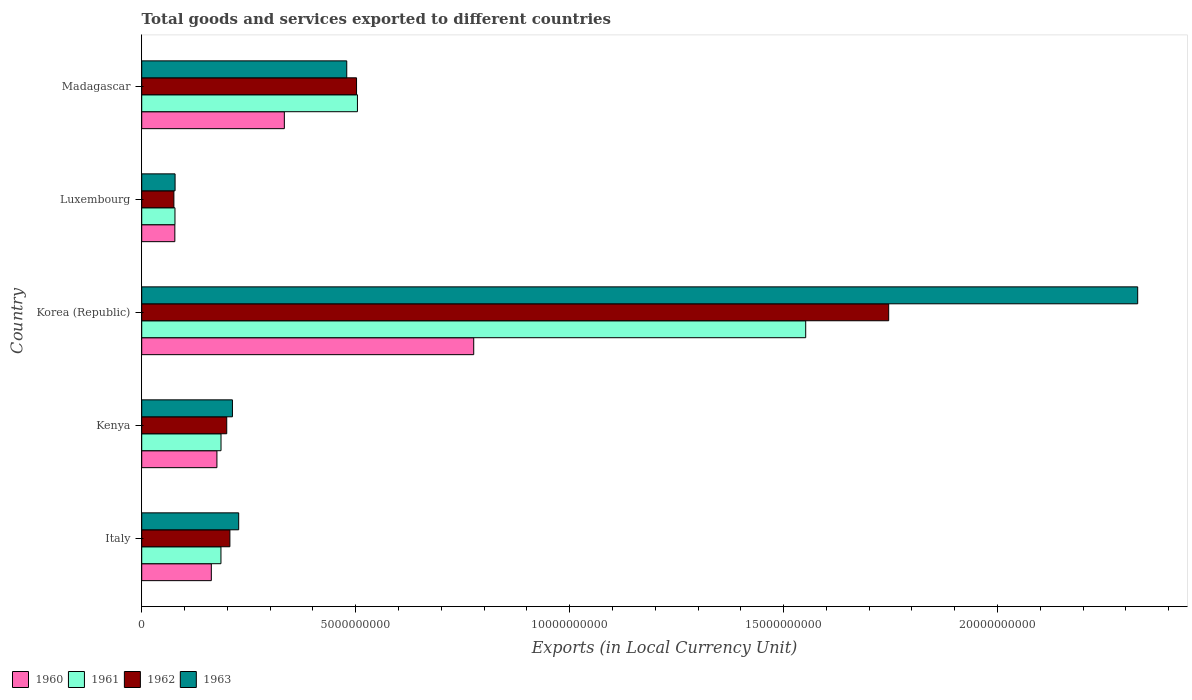How many different coloured bars are there?
Offer a terse response. 4. How many groups of bars are there?
Ensure brevity in your answer.  5. How many bars are there on the 4th tick from the top?
Ensure brevity in your answer.  4. What is the label of the 5th group of bars from the top?
Your answer should be compact. Italy. What is the Amount of goods and services exports in 1961 in Kenya?
Offer a very short reply. 1.85e+09. Across all countries, what is the maximum Amount of goods and services exports in 1960?
Make the answer very short. 7.76e+09. Across all countries, what is the minimum Amount of goods and services exports in 1962?
Keep it short and to the point. 7.52e+08. In which country was the Amount of goods and services exports in 1962 minimum?
Keep it short and to the point. Luxembourg. What is the total Amount of goods and services exports in 1960 in the graph?
Give a very brief answer. 1.52e+1. What is the difference between the Amount of goods and services exports in 1961 in Italy and that in Madagascar?
Provide a succinct answer. -3.19e+09. What is the difference between the Amount of goods and services exports in 1961 in Italy and the Amount of goods and services exports in 1963 in Kenya?
Offer a terse response. -2.68e+08. What is the average Amount of goods and services exports in 1962 per country?
Your response must be concise. 5.46e+09. What is the difference between the Amount of goods and services exports in 1960 and Amount of goods and services exports in 1963 in Madagascar?
Provide a short and direct response. -1.46e+09. What is the ratio of the Amount of goods and services exports in 1961 in Kenya to that in Korea (Republic)?
Make the answer very short. 0.12. Is the difference between the Amount of goods and services exports in 1960 in Kenya and Korea (Republic) greater than the difference between the Amount of goods and services exports in 1963 in Kenya and Korea (Republic)?
Keep it short and to the point. Yes. What is the difference between the highest and the second highest Amount of goods and services exports in 1960?
Provide a succinct answer. 4.43e+09. What is the difference between the highest and the lowest Amount of goods and services exports in 1963?
Give a very brief answer. 2.25e+1. Is the sum of the Amount of goods and services exports in 1960 in Italy and Kenya greater than the maximum Amount of goods and services exports in 1961 across all countries?
Ensure brevity in your answer.  No. Is it the case that in every country, the sum of the Amount of goods and services exports in 1961 and Amount of goods and services exports in 1960 is greater than the sum of Amount of goods and services exports in 1963 and Amount of goods and services exports in 1962?
Offer a terse response. No. Is it the case that in every country, the sum of the Amount of goods and services exports in 1961 and Amount of goods and services exports in 1963 is greater than the Amount of goods and services exports in 1960?
Ensure brevity in your answer.  Yes. Are all the bars in the graph horizontal?
Your answer should be compact. Yes. What is the difference between two consecutive major ticks on the X-axis?
Give a very brief answer. 5.00e+09. Are the values on the major ticks of X-axis written in scientific E-notation?
Ensure brevity in your answer.  No. Does the graph contain any zero values?
Your response must be concise. No. Does the graph contain grids?
Your answer should be compact. No. What is the title of the graph?
Your answer should be compact. Total goods and services exported to different countries. Does "1976" appear as one of the legend labels in the graph?
Your answer should be compact. No. What is the label or title of the X-axis?
Provide a short and direct response. Exports (in Local Currency Unit). What is the Exports (in Local Currency Unit) in 1960 in Italy?
Give a very brief answer. 1.63e+09. What is the Exports (in Local Currency Unit) in 1961 in Italy?
Make the answer very short. 1.85e+09. What is the Exports (in Local Currency Unit) in 1962 in Italy?
Offer a terse response. 2.06e+09. What is the Exports (in Local Currency Unit) of 1963 in Italy?
Ensure brevity in your answer.  2.27e+09. What is the Exports (in Local Currency Unit) of 1960 in Kenya?
Ensure brevity in your answer.  1.76e+09. What is the Exports (in Local Currency Unit) in 1961 in Kenya?
Your response must be concise. 1.85e+09. What is the Exports (in Local Currency Unit) in 1962 in Kenya?
Ensure brevity in your answer.  1.99e+09. What is the Exports (in Local Currency Unit) of 1963 in Kenya?
Your answer should be very brief. 2.12e+09. What is the Exports (in Local Currency Unit) in 1960 in Korea (Republic)?
Provide a succinct answer. 7.76e+09. What is the Exports (in Local Currency Unit) of 1961 in Korea (Republic)?
Offer a very short reply. 1.55e+1. What is the Exports (in Local Currency Unit) of 1962 in Korea (Republic)?
Give a very brief answer. 1.75e+1. What is the Exports (in Local Currency Unit) in 1963 in Korea (Republic)?
Give a very brief answer. 2.33e+1. What is the Exports (in Local Currency Unit) of 1960 in Luxembourg?
Your answer should be compact. 7.74e+08. What is the Exports (in Local Currency Unit) in 1961 in Luxembourg?
Offer a terse response. 7.77e+08. What is the Exports (in Local Currency Unit) of 1962 in Luxembourg?
Keep it short and to the point. 7.52e+08. What is the Exports (in Local Currency Unit) in 1963 in Luxembourg?
Offer a very short reply. 7.80e+08. What is the Exports (in Local Currency Unit) in 1960 in Madagascar?
Keep it short and to the point. 3.33e+09. What is the Exports (in Local Currency Unit) of 1961 in Madagascar?
Make the answer very short. 5.04e+09. What is the Exports (in Local Currency Unit) in 1962 in Madagascar?
Make the answer very short. 5.02e+09. What is the Exports (in Local Currency Unit) of 1963 in Madagascar?
Your answer should be compact. 4.79e+09. Across all countries, what is the maximum Exports (in Local Currency Unit) in 1960?
Offer a terse response. 7.76e+09. Across all countries, what is the maximum Exports (in Local Currency Unit) in 1961?
Keep it short and to the point. 1.55e+1. Across all countries, what is the maximum Exports (in Local Currency Unit) in 1962?
Offer a terse response. 1.75e+1. Across all countries, what is the maximum Exports (in Local Currency Unit) of 1963?
Ensure brevity in your answer.  2.33e+1. Across all countries, what is the minimum Exports (in Local Currency Unit) in 1960?
Provide a short and direct response. 7.74e+08. Across all countries, what is the minimum Exports (in Local Currency Unit) of 1961?
Give a very brief answer. 7.77e+08. Across all countries, what is the minimum Exports (in Local Currency Unit) in 1962?
Keep it short and to the point. 7.52e+08. Across all countries, what is the minimum Exports (in Local Currency Unit) of 1963?
Provide a succinct answer. 7.80e+08. What is the total Exports (in Local Currency Unit) of 1960 in the graph?
Your answer should be very brief. 1.52e+1. What is the total Exports (in Local Currency Unit) of 1961 in the graph?
Your answer should be compact. 2.50e+1. What is the total Exports (in Local Currency Unit) of 1962 in the graph?
Offer a very short reply. 2.73e+1. What is the total Exports (in Local Currency Unit) in 1963 in the graph?
Offer a terse response. 3.32e+1. What is the difference between the Exports (in Local Currency Unit) of 1960 in Italy and that in Kenya?
Keep it short and to the point. -1.31e+08. What is the difference between the Exports (in Local Currency Unit) of 1961 in Italy and that in Kenya?
Keep it short and to the point. -1.45e+06. What is the difference between the Exports (in Local Currency Unit) of 1962 in Italy and that in Kenya?
Your answer should be very brief. 7.40e+07. What is the difference between the Exports (in Local Currency Unit) of 1963 in Italy and that in Kenya?
Your response must be concise. 1.46e+08. What is the difference between the Exports (in Local Currency Unit) in 1960 in Italy and that in Korea (Republic)?
Offer a very short reply. -6.13e+09. What is the difference between the Exports (in Local Currency Unit) in 1961 in Italy and that in Korea (Republic)?
Offer a terse response. -1.37e+1. What is the difference between the Exports (in Local Currency Unit) in 1962 in Italy and that in Korea (Republic)?
Keep it short and to the point. -1.54e+1. What is the difference between the Exports (in Local Currency Unit) in 1963 in Italy and that in Korea (Republic)?
Your answer should be compact. -2.10e+1. What is the difference between the Exports (in Local Currency Unit) in 1960 in Italy and that in Luxembourg?
Provide a short and direct response. 8.53e+08. What is the difference between the Exports (in Local Currency Unit) in 1961 in Italy and that in Luxembourg?
Make the answer very short. 1.07e+09. What is the difference between the Exports (in Local Currency Unit) of 1962 in Italy and that in Luxembourg?
Your response must be concise. 1.31e+09. What is the difference between the Exports (in Local Currency Unit) of 1963 in Italy and that in Luxembourg?
Keep it short and to the point. 1.49e+09. What is the difference between the Exports (in Local Currency Unit) in 1960 in Italy and that in Madagascar?
Keep it short and to the point. -1.71e+09. What is the difference between the Exports (in Local Currency Unit) of 1961 in Italy and that in Madagascar?
Keep it short and to the point. -3.19e+09. What is the difference between the Exports (in Local Currency Unit) of 1962 in Italy and that in Madagascar?
Give a very brief answer. -2.96e+09. What is the difference between the Exports (in Local Currency Unit) in 1963 in Italy and that in Madagascar?
Your response must be concise. -2.53e+09. What is the difference between the Exports (in Local Currency Unit) of 1960 in Kenya and that in Korea (Republic)?
Offer a very short reply. -6.00e+09. What is the difference between the Exports (in Local Currency Unit) in 1961 in Kenya and that in Korea (Republic)?
Offer a terse response. -1.37e+1. What is the difference between the Exports (in Local Currency Unit) of 1962 in Kenya and that in Korea (Republic)?
Give a very brief answer. -1.55e+1. What is the difference between the Exports (in Local Currency Unit) of 1963 in Kenya and that in Korea (Republic)?
Make the answer very short. -2.12e+1. What is the difference between the Exports (in Local Currency Unit) in 1960 in Kenya and that in Luxembourg?
Provide a short and direct response. 9.84e+08. What is the difference between the Exports (in Local Currency Unit) of 1961 in Kenya and that in Luxembourg?
Your answer should be very brief. 1.08e+09. What is the difference between the Exports (in Local Currency Unit) in 1962 in Kenya and that in Luxembourg?
Your answer should be compact. 1.23e+09. What is the difference between the Exports (in Local Currency Unit) in 1963 in Kenya and that in Luxembourg?
Give a very brief answer. 1.34e+09. What is the difference between the Exports (in Local Currency Unit) of 1960 in Kenya and that in Madagascar?
Ensure brevity in your answer.  -1.58e+09. What is the difference between the Exports (in Local Currency Unit) in 1961 in Kenya and that in Madagascar?
Your answer should be compact. -3.19e+09. What is the difference between the Exports (in Local Currency Unit) of 1962 in Kenya and that in Madagascar?
Offer a very short reply. -3.03e+09. What is the difference between the Exports (in Local Currency Unit) in 1963 in Kenya and that in Madagascar?
Keep it short and to the point. -2.67e+09. What is the difference between the Exports (in Local Currency Unit) in 1960 in Korea (Republic) and that in Luxembourg?
Your answer should be compact. 6.98e+09. What is the difference between the Exports (in Local Currency Unit) of 1961 in Korea (Republic) and that in Luxembourg?
Offer a terse response. 1.47e+1. What is the difference between the Exports (in Local Currency Unit) in 1962 in Korea (Republic) and that in Luxembourg?
Keep it short and to the point. 1.67e+1. What is the difference between the Exports (in Local Currency Unit) in 1963 in Korea (Republic) and that in Luxembourg?
Make the answer very short. 2.25e+1. What is the difference between the Exports (in Local Currency Unit) of 1960 in Korea (Republic) and that in Madagascar?
Offer a very short reply. 4.43e+09. What is the difference between the Exports (in Local Currency Unit) of 1961 in Korea (Republic) and that in Madagascar?
Make the answer very short. 1.05e+1. What is the difference between the Exports (in Local Currency Unit) in 1962 in Korea (Republic) and that in Madagascar?
Keep it short and to the point. 1.24e+1. What is the difference between the Exports (in Local Currency Unit) in 1963 in Korea (Republic) and that in Madagascar?
Your answer should be very brief. 1.85e+1. What is the difference between the Exports (in Local Currency Unit) in 1960 in Luxembourg and that in Madagascar?
Provide a succinct answer. -2.56e+09. What is the difference between the Exports (in Local Currency Unit) in 1961 in Luxembourg and that in Madagascar?
Provide a succinct answer. -4.26e+09. What is the difference between the Exports (in Local Currency Unit) of 1962 in Luxembourg and that in Madagascar?
Your answer should be very brief. -4.27e+09. What is the difference between the Exports (in Local Currency Unit) in 1963 in Luxembourg and that in Madagascar?
Provide a short and direct response. -4.01e+09. What is the difference between the Exports (in Local Currency Unit) in 1960 in Italy and the Exports (in Local Currency Unit) in 1961 in Kenya?
Provide a succinct answer. -2.27e+08. What is the difference between the Exports (in Local Currency Unit) in 1960 in Italy and the Exports (in Local Currency Unit) in 1962 in Kenya?
Make the answer very short. -3.60e+08. What is the difference between the Exports (in Local Currency Unit) of 1960 in Italy and the Exports (in Local Currency Unit) of 1963 in Kenya?
Provide a succinct answer. -4.94e+08. What is the difference between the Exports (in Local Currency Unit) in 1961 in Italy and the Exports (in Local Currency Unit) in 1962 in Kenya?
Your answer should be compact. -1.35e+08. What is the difference between the Exports (in Local Currency Unit) of 1961 in Italy and the Exports (in Local Currency Unit) of 1963 in Kenya?
Make the answer very short. -2.68e+08. What is the difference between the Exports (in Local Currency Unit) of 1962 in Italy and the Exports (in Local Currency Unit) of 1963 in Kenya?
Provide a short and direct response. -5.95e+07. What is the difference between the Exports (in Local Currency Unit) of 1960 in Italy and the Exports (in Local Currency Unit) of 1961 in Korea (Republic)?
Give a very brief answer. -1.39e+1. What is the difference between the Exports (in Local Currency Unit) in 1960 in Italy and the Exports (in Local Currency Unit) in 1962 in Korea (Republic)?
Your answer should be very brief. -1.58e+1. What is the difference between the Exports (in Local Currency Unit) in 1960 in Italy and the Exports (in Local Currency Unit) in 1963 in Korea (Republic)?
Your answer should be very brief. -2.16e+1. What is the difference between the Exports (in Local Currency Unit) of 1961 in Italy and the Exports (in Local Currency Unit) of 1962 in Korea (Republic)?
Provide a succinct answer. -1.56e+1. What is the difference between the Exports (in Local Currency Unit) of 1961 in Italy and the Exports (in Local Currency Unit) of 1963 in Korea (Republic)?
Offer a very short reply. -2.14e+1. What is the difference between the Exports (in Local Currency Unit) of 1962 in Italy and the Exports (in Local Currency Unit) of 1963 in Korea (Republic)?
Make the answer very short. -2.12e+1. What is the difference between the Exports (in Local Currency Unit) in 1960 in Italy and the Exports (in Local Currency Unit) in 1961 in Luxembourg?
Ensure brevity in your answer.  8.50e+08. What is the difference between the Exports (in Local Currency Unit) of 1960 in Italy and the Exports (in Local Currency Unit) of 1962 in Luxembourg?
Keep it short and to the point. 8.75e+08. What is the difference between the Exports (in Local Currency Unit) of 1960 in Italy and the Exports (in Local Currency Unit) of 1963 in Luxembourg?
Your answer should be very brief. 8.47e+08. What is the difference between the Exports (in Local Currency Unit) in 1961 in Italy and the Exports (in Local Currency Unit) in 1962 in Luxembourg?
Your answer should be compact. 1.10e+09. What is the difference between the Exports (in Local Currency Unit) of 1961 in Italy and the Exports (in Local Currency Unit) of 1963 in Luxembourg?
Offer a terse response. 1.07e+09. What is the difference between the Exports (in Local Currency Unit) in 1962 in Italy and the Exports (in Local Currency Unit) in 1963 in Luxembourg?
Your response must be concise. 1.28e+09. What is the difference between the Exports (in Local Currency Unit) in 1960 in Italy and the Exports (in Local Currency Unit) in 1961 in Madagascar?
Provide a succinct answer. -3.41e+09. What is the difference between the Exports (in Local Currency Unit) of 1960 in Italy and the Exports (in Local Currency Unit) of 1962 in Madagascar?
Your answer should be compact. -3.39e+09. What is the difference between the Exports (in Local Currency Unit) in 1960 in Italy and the Exports (in Local Currency Unit) in 1963 in Madagascar?
Offer a terse response. -3.16e+09. What is the difference between the Exports (in Local Currency Unit) in 1961 in Italy and the Exports (in Local Currency Unit) in 1962 in Madagascar?
Your answer should be compact. -3.17e+09. What is the difference between the Exports (in Local Currency Unit) of 1961 in Italy and the Exports (in Local Currency Unit) of 1963 in Madagascar?
Keep it short and to the point. -2.94e+09. What is the difference between the Exports (in Local Currency Unit) of 1962 in Italy and the Exports (in Local Currency Unit) of 1963 in Madagascar?
Offer a very short reply. -2.73e+09. What is the difference between the Exports (in Local Currency Unit) of 1960 in Kenya and the Exports (in Local Currency Unit) of 1961 in Korea (Republic)?
Your response must be concise. -1.38e+1. What is the difference between the Exports (in Local Currency Unit) in 1960 in Kenya and the Exports (in Local Currency Unit) in 1962 in Korea (Republic)?
Your response must be concise. -1.57e+1. What is the difference between the Exports (in Local Currency Unit) of 1960 in Kenya and the Exports (in Local Currency Unit) of 1963 in Korea (Republic)?
Provide a short and direct response. -2.15e+1. What is the difference between the Exports (in Local Currency Unit) of 1961 in Kenya and the Exports (in Local Currency Unit) of 1962 in Korea (Republic)?
Ensure brevity in your answer.  -1.56e+1. What is the difference between the Exports (in Local Currency Unit) in 1961 in Kenya and the Exports (in Local Currency Unit) in 1963 in Korea (Republic)?
Your answer should be very brief. -2.14e+1. What is the difference between the Exports (in Local Currency Unit) of 1962 in Kenya and the Exports (in Local Currency Unit) of 1963 in Korea (Republic)?
Provide a succinct answer. -2.13e+1. What is the difference between the Exports (in Local Currency Unit) in 1960 in Kenya and the Exports (in Local Currency Unit) in 1961 in Luxembourg?
Give a very brief answer. 9.81e+08. What is the difference between the Exports (in Local Currency Unit) of 1960 in Kenya and the Exports (in Local Currency Unit) of 1962 in Luxembourg?
Ensure brevity in your answer.  1.01e+09. What is the difference between the Exports (in Local Currency Unit) in 1960 in Kenya and the Exports (in Local Currency Unit) in 1963 in Luxembourg?
Offer a very short reply. 9.78e+08. What is the difference between the Exports (in Local Currency Unit) in 1961 in Kenya and the Exports (in Local Currency Unit) in 1962 in Luxembourg?
Keep it short and to the point. 1.10e+09. What is the difference between the Exports (in Local Currency Unit) of 1961 in Kenya and the Exports (in Local Currency Unit) of 1963 in Luxembourg?
Ensure brevity in your answer.  1.07e+09. What is the difference between the Exports (in Local Currency Unit) of 1962 in Kenya and the Exports (in Local Currency Unit) of 1963 in Luxembourg?
Your response must be concise. 1.21e+09. What is the difference between the Exports (in Local Currency Unit) of 1960 in Kenya and the Exports (in Local Currency Unit) of 1961 in Madagascar?
Make the answer very short. -3.28e+09. What is the difference between the Exports (in Local Currency Unit) in 1960 in Kenya and the Exports (in Local Currency Unit) in 1962 in Madagascar?
Keep it short and to the point. -3.26e+09. What is the difference between the Exports (in Local Currency Unit) in 1960 in Kenya and the Exports (in Local Currency Unit) in 1963 in Madagascar?
Ensure brevity in your answer.  -3.03e+09. What is the difference between the Exports (in Local Currency Unit) in 1961 in Kenya and the Exports (in Local Currency Unit) in 1962 in Madagascar?
Your response must be concise. -3.17e+09. What is the difference between the Exports (in Local Currency Unit) of 1961 in Kenya and the Exports (in Local Currency Unit) of 1963 in Madagascar?
Offer a very short reply. -2.94e+09. What is the difference between the Exports (in Local Currency Unit) in 1962 in Kenya and the Exports (in Local Currency Unit) in 1963 in Madagascar?
Provide a short and direct response. -2.80e+09. What is the difference between the Exports (in Local Currency Unit) of 1960 in Korea (Republic) and the Exports (in Local Currency Unit) of 1961 in Luxembourg?
Your response must be concise. 6.98e+09. What is the difference between the Exports (in Local Currency Unit) of 1960 in Korea (Republic) and the Exports (in Local Currency Unit) of 1962 in Luxembourg?
Offer a very short reply. 7.01e+09. What is the difference between the Exports (in Local Currency Unit) of 1960 in Korea (Republic) and the Exports (in Local Currency Unit) of 1963 in Luxembourg?
Make the answer very short. 6.98e+09. What is the difference between the Exports (in Local Currency Unit) of 1961 in Korea (Republic) and the Exports (in Local Currency Unit) of 1962 in Luxembourg?
Offer a terse response. 1.48e+1. What is the difference between the Exports (in Local Currency Unit) in 1961 in Korea (Republic) and the Exports (in Local Currency Unit) in 1963 in Luxembourg?
Offer a terse response. 1.47e+1. What is the difference between the Exports (in Local Currency Unit) of 1962 in Korea (Republic) and the Exports (in Local Currency Unit) of 1963 in Luxembourg?
Make the answer very short. 1.67e+1. What is the difference between the Exports (in Local Currency Unit) in 1960 in Korea (Republic) and the Exports (in Local Currency Unit) in 1961 in Madagascar?
Keep it short and to the point. 2.72e+09. What is the difference between the Exports (in Local Currency Unit) of 1960 in Korea (Republic) and the Exports (in Local Currency Unit) of 1962 in Madagascar?
Your answer should be very brief. 2.74e+09. What is the difference between the Exports (in Local Currency Unit) of 1960 in Korea (Republic) and the Exports (in Local Currency Unit) of 1963 in Madagascar?
Provide a succinct answer. 2.97e+09. What is the difference between the Exports (in Local Currency Unit) in 1961 in Korea (Republic) and the Exports (in Local Currency Unit) in 1962 in Madagascar?
Your answer should be compact. 1.05e+1. What is the difference between the Exports (in Local Currency Unit) in 1961 in Korea (Republic) and the Exports (in Local Currency Unit) in 1963 in Madagascar?
Your answer should be compact. 1.07e+1. What is the difference between the Exports (in Local Currency Unit) of 1962 in Korea (Republic) and the Exports (in Local Currency Unit) of 1963 in Madagascar?
Provide a short and direct response. 1.27e+1. What is the difference between the Exports (in Local Currency Unit) in 1960 in Luxembourg and the Exports (in Local Currency Unit) in 1961 in Madagascar?
Your response must be concise. -4.27e+09. What is the difference between the Exports (in Local Currency Unit) in 1960 in Luxembourg and the Exports (in Local Currency Unit) in 1962 in Madagascar?
Keep it short and to the point. -4.25e+09. What is the difference between the Exports (in Local Currency Unit) in 1960 in Luxembourg and the Exports (in Local Currency Unit) in 1963 in Madagascar?
Offer a terse response. -4.02e+09. What is the difference between the Exports (in Local Currency Unit) in 1961 in Luxembourg and the Exports (in Local Currency Unit) in 1962 in Madagascar?
Make the answer very short. -4.24e+09. What is the difference between the Exports (in Local Currency Unit) in 1961 in Luxembourg and the Exports (in Local Currency Unit) in 1963 in Madagascar?
Your answer should be compact. -4.01e+09. What is the difference between the Exports (in Local Currency Unit) in 1962 in Luxembourg and the Exports (in Local Currency Unit) in 1963 in Madagascar?
Offer a very short reply. -4.04e+09. What is the average Exports (in Local Currency Unit) in 1960 per country?
Ensure brevity in your answer.  3.05e+09. What is the average Exports (in Local Currency Unit) of 1961 per country?
Offer a terse response. 5.01e+09. What is the average Exports (in Local Currency Unit) of 1962 per country?
Provide a short and direct response. 5.46e+09. What is the average Exports (in Local Currency Unit) in 1963 per country?
Provide a short and direct response. 6.65e+09. What is the difference between the Exports (in Local Currency Unit) in 1960 and Exports (in Local Currency Unit) in 1961 in Italy?
Offer a terse response. -2.25e+08. What is the difference between the Exports (in Local Currency Unit) of 1960 and Exports (in Local Currency Unit) of 1962 in Italy?
Keep it short and to the point. -4.34e+08. What is the difference between the Exports (in Local Currency Unit) in 1960 and Exports (in Local Currency Unit) in 1963 in Italy?
Offer a very short reply. -6.40e+08. What is the difference between the Exports (in Local Currency Unit) of 1961 and Exports (in Local Currency Unit) of 1962 in Italy?
Offer a terse response. -2.09e+08. What is the difference between the Exports (in Local Currency Unit) of 1961 and Exports (in Local Currency Unit) of 1963 in Italy?
Give a very brief answer. -4.14e+08. What is the difference between the Exports (in Local Currency Unit) in 1962 and Exports (in Local Currency Unit) in 1963 in Italy?
Your answer should be very brief. -2.05e+08. What is the difference between the Exports (in Local Currency Unit) of 1960 and Exports (in Local Currency Unit) of 1961 in Kenya?
Your answer should be compact. -9.56e+07. What is the difference between the Exports (in Local Currency Unit) in 1960 and Exports (in Local Currency Unit) in 1962 in Kenya?
Provide a succinct answer. -2.29e+08. What is the difference between the Exports (in Local Currency Unit) in 1960 and Exports (in Local Currency Unit) in 1963 in Kenya?
Your answer should be very brief. -3.63e+08. What is the difference between the Exports (in Local Currency Unit) in 1961 and Exports (in Local Currency Unit) in 1962 in Kenya?
Give a very brief answer. -1.33e+08. What is the difference between the Exports (in Local Currency Unit) of 1961 and Exports (in Local Currency Unit) of 1963 in Kenya?
Provide a succinct answer. -2.67e+08. What is the difference between the Exports (in Local Currency Unit) of 1962 and Exports (in Local Currency Unit) of 1963 in Kenya?
Keep it short and to the point. -1.34e+08. What is the difference between the Exports (in Local Currency Unit) in 1960 and Exports (in Local Currency Unit) in 1961 in Korea (Republic)?
Ensure brevity in your answer.  -7.76e+09. What is the difference between the Exports (in Local Currency Unit) in 1960 and Exports (in Local Currency Unit) in 1962 in Korea (Republic)?
Provide a succinct answer. -9.70e+09. What is the difference between the Exports (in Local Currency Unit) in 1960 and Exports (in Local Currency Unit) in 1963 in Korea (Republic)?
Offer a terse response. -1.55e+1. What is the difference between the Exports (in Local Currency Unit) of 1961 and Exports (in Local Currency Unit) of 1962 in Korea (Republic)?
Offer a terse response. -1.94e+09. What is the difference between the Exports (in Local Currency Unit) of 1961 and Exports (in Local Currency Unit) of 1963 in Korea (Republic)?
Offer a terse response. -7.76e+09. What is the difference between the Exports (in Local Currency Unit) in 1962 and Exports (in Local Currency Unit) in 1963 in Korea (Republic)?
Your answer should be compact. -5.82e+09. What is the difference between the Exports (in Local Currency Unit) in 1960 and Exports (in Local Currency Unit) in 1961 in Luxembourg?
Provide a short and direct response. -2.86e+06. What is the difference between the Exports (in Local Currency Unit) in 1960 and Exports (in Local Currency Unit) in 1962 in Luxembourg?
Give a very brief answer. 2.23e+07. What is the difference between the Exports (in Local Currency Unit) of 1960 and Exports (in Local Currency Unit) of 1963 in Luxembourg?
Your response must be concise. -5.65e+06. What is the difference between the Exports (in Local Currency Unit) of 1961 and Exports (in Local Currency Unit) of 1962 in Luxembourg?
Ensure brevity in your answer.  2.52e+07. What is the difference between the Exports (in Local Currency Unit) of 1961 and Exports (in Local Currency Unit) of 1963 in Luxembourg?
Offer a terse response. -2.79e+06. What is the difference between the Exports (in Local Currency Unit) in 1962 and Exports (in Local Currency Unit) in 1963 in Luxembourg?
Offer a terse response. -2.80e+07. What is the difference between the Exports (in Local Currency Unit) of 1960 and Exports (in Local Currency Unit) of 1961 in Madagascar?
Ensure brevity in your answer.  -1.71e+09. What is the difference between the Exports (in Local Currency Unit) of 1960 and Exports (in Local Currency Unit) of 1962 in Madagascar?
Your answer should be compact. -1.69e+09. What is the difference between the Exports (in Local Currency Unit) in 1960 and Exports (in Local Currency Unit) in 1963 in Madagascar?
Give a very brief answer. -1.46e+09. What is the difference between the Exports (in Local Currency Unit) of 1961 and Exports (in Local Currency Unit) of 1962 in Madagascar?
Provide a short and direct response. 2.08e+07. What is the difference between the Exports (in Local Currency Unit) in 1961 and Exports (in Local Currency Unit) in 1963 in Madagascar?
Offer a very short reply. 2.50e+08. What is the difference between the Exports (in Local Currency Unit) of 1962 and Exports (in Local Currency Unit) of 1963 in Madagascar?
Offer a terse response. 2.29e+08. What is the ratio of the Exports (in Local Currency Unit) in 1960 in Italy to that in Kenya?
Your response must be concise. 0.93. What is the ratio of the Exports (in Local Currency Unit) of 1961 in Italy to that in Kenya?
Make the answer very short. 1. What is the ratio of the Exports (in Local Currency Unit) of 1962 in Italy to that in Kenya?
Ensure brevity in your answer.  1.04. What is the ratio of the Exports (in Local Currency Unit) of 1963 in Italy to that in Kenya?
Your response must be concise. 1.07. What is the ratio of the Exports (in Local Currency Unit) of 1960 in Italy to that in Korea (Republic)?
Your answer should be very brief. 0.21. What is the ratio of the Exports (in Local Currency Unit) of 1961 in Italy to that in Korea (Republic)?
Make the answer very short. 0.12. What is the ratio of the Exports (in Local Currency Unit) in 1962 in Italy to that in Korea (Republic)?
Make the answer very short. 0.12. What is the ratio of the Exports (in Local Currency Unit) in 1963 in Italy to that in Korea (Republic)?
Give a very brief answer. 0.1. What is the ratio of the Exports (in Local Currency Unit) of 1960 in Italy to that in Luxembourg?
Provide a succinct answer. 2.1. What is the ratio of the Exports (in Local Currency Unit) of 1961 in Italy to that in Luxembourg?
Your response must be concise. 2.38. What is the ratio of the Exports (in Local Currency Unit) of 1962 in Italy to that in Luxembourg?
Your response must be concise. 2.74. What is the ratio of the Exports (in Local Currency Unit) of 1963 in Italy to that in Luxembourg?
Offer a very short reply. 2.91. What is the ratio of the Exports (in Local Currency Unit) of 1960 in Italy to that in Madagascar?
Provide a succinct answer. 0.49. What is the ratio of the Exports (in Local Currency Unit) of 1961 in Italy to that in Madagascar?
Provide a succinct answer. 0.37. What is the ratio of the Exports (in Local Currency Unit) in 1962 in Italy to that in Madagascar?
Make the answer very short. 0.41. What is the ratio of the Exports (in Local Currency Unit) of 1963 in Italy to that in Madagascar?
Provide a short and direct response. 0.47. What is the ratio of the Exports (in Local Currency Unit) in 1960 in Kenya to that in Korea (Republic)?
Your answer should be very brief. 0.23. What is the ratio of the Exports (in Local Currency Unit) of 1961 in Kenya to that in Korea (Republic)?
Your answer should be very brief. 0.12. What is the ratio of the Exports (in Local Currency Unit) in 1962 in Kenya to that in Korea (Republic)?
Your answer should be very brief. 0.11. What is the ratio of the Exports (in Local Currency Unit) of 1963 in Kenya to that in Korea (Republic)?
Make the answer very short. 0.09. What is the ratio of the Exports (in Local Currency Unit) in 1960 in Kenya to that in Luxembourg?
Provide a short and direct response. 2.27. What is the ratio of the Exports (in Local Currency Unit) of 1961 in Kenya to that in Luxembourg?
Your answer should be compact. 2.39. What is the ratio of the Exports (in Local Currency Unit) in 1962 in Kenya to that in Luxembourg?
Your answer should be very brief. 2.64. What is the ratio of the Exports (in Local Currency Unit) of 1963 in Kenya to that in Luxembourg?
Give a very brief answer. 2.72. What is the ratio of the Exports (in Local Currency Unit) in 1960 in Kenya to that in Madagascar?
Provide a succinct answer. 0.53. What is the ratio of the Exports (in Local Currency Unit) of 1961 in Kenya to that in Madagascar?
Provide a short and direct response. 0.37. What is the ratio of the Exports (in Local Currency Unit) of 1962 in Kenya to that in Madagascar?
Give a very brief answer. 0.4. What is the ratio of the Exports (in Local Currency Unit) of 1963 in Kenya to that in Madagascar?
Your answer should be compact. 0.44. What is the ratio of the Exports (in Local Currency Unit) of 1960 in Korea (Republic) to that in Luxembourg?
Your response must be concise. 10.02. What is the ratio of the Exports (in Local Currency Unit) in 1961 in Korea (Republic) to that in Luxembourg?
Make the answer very short. 19.97. What is the ratio of the Exports (in Local Currency Unit) in 1962 in Korea (Republic) to that in Luxembourg?
Your response must be concise. 23.22. What is the ratio of the Exports (in Local Currency Unit) in 1963 in Korea (Republic) to that in Luxembourg?
Keep it short and to the point. 29.85. What is the ratio of the Exports (in Local Currency Unit) in 1960 in Korea (Republic) to that in Madagascar?
Your response must be concise. 2.33. What is the ratio of the Exports (in Local Currency Unit) of 1961 in Korea (Republic) to that in Madagascar?
Your response must be concise. 3.08. What is the ratio of the Exports (in Local Currency Unit) in 1962 in Korea (Republic) to that in Madagascar?
Make the answer very short. 3.48. What is the ratio of the Exports (in Local Currency Unit) in 1963 in Korea (Republic) to that in Madagascar?
Offer a terse response. 4.86. What is the ratio of the Exports (in Local Currency Unit) in 1960 in Luxembourg to that in Madagascar?
Provide a short and direct response. 0.23. What is the ratio of the Exports (in Local Currency Unit) in 1961 in Luxembourg to that in Madagascar?
Offer a terse response. 0.15. What is the ratio of the Exports (in Local Currency Unit) in 1962 in Luxembourg to that in Madagascar?
Provide a short and direct response. 0.15. What is the ratio of the Exports (in Local Currency Unit) in 1963 in Luxembourg to that in Madagascar?
Ensure brevity in your answer.  0.16. What is the difference between the highest and the second highest Exports (in Local Currency Unit) in 1960?
Provide a succinct answer. 4.43e+09. What is the difference between the highest and the second highest Exports (in Local Currency Unit) of 1961?
Ensure brevity in your answer.  1.05e+1. What is the difference between the highest and the second highest Exports (in Local Currency Unit) in 1962?
Your response must be concise. 1.24e+1. What is the difference between the highest and the second highest Exports (in Local Currency Unit) in 1963?
Provide a succinct answer. 1.85e+1. What is the difference between the highest and the lowest Exports (in Local Currency Unit) of 1960?
Make the answer very short. 6.98e+09. What is the difference between the highest and the lowest Exports (in Local Currency Unit) of 1961?
Provide a short and direct response. 1.47e+1. What is the difference between the highest and the lowest Exports (in Local Currency Unit) of 1962?
Provide a succinct answer. 1.67e+1. What is the difference between the highest and the lowest Exports (in Local Currency Unit) in 1963?
Your answer should be compact. 2.25e+1. 